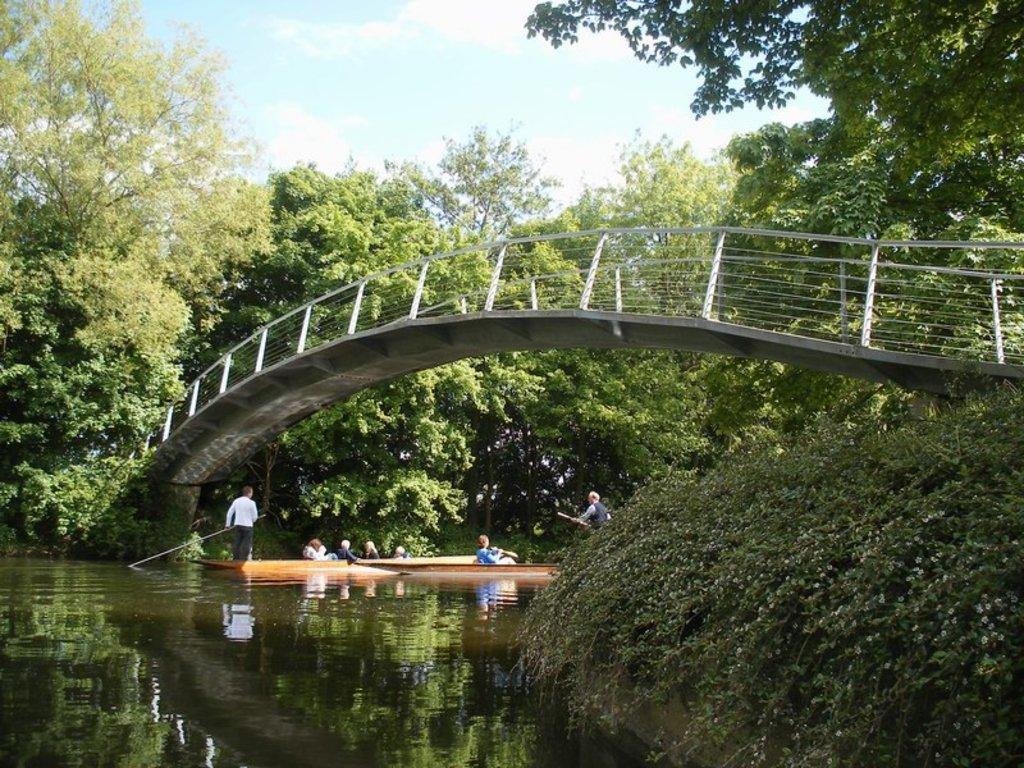How would you summarize this image in a sentence or two? In this image we can see some people sitting in a boat which is in a water body. In that two men are standing in a boat holding the rows. We can also see a bridge, some plants, a group of trees and the sky which looks cloudy. 